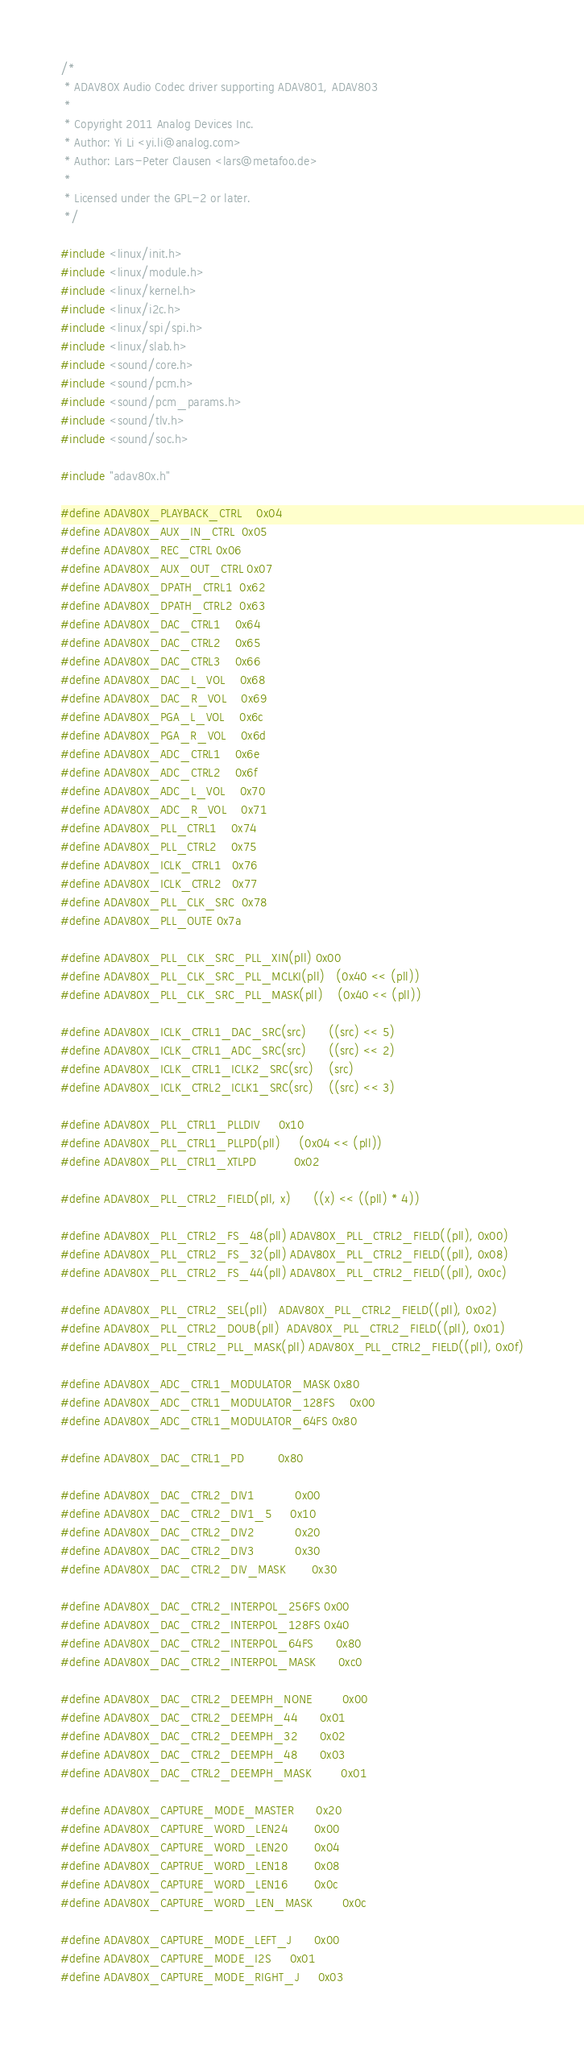Convert code to text. <code><loc_0><loc_0><loc_500><loc_500><_C_>/*
 * ADAV80X Audio Codec driver supporting ADAV801, ADAV803
 *
 * Copyright 2011 Analog Devices Inc.
 * Author: Yi Li <yi.li@analog.com>
 * Author: Lars-Peter Clausen <lars@metafoo.de>
 *
 * Licensed under the GPL-2 or later.
 */

#include <linux/init.h>
#include <linux/module.h>
#include <linux/kernel.h>
#include <linux/i2c.h>
#include <linux/spi/spi.h>
#include <linux/slab.h>
#include <sound/core.h>
#include <sound/pcm.h>
#include <sound/pcm_params.h>
#include <sound/tlv.h>
#include <sound/soc.h>

#include "adav80x.h"

#define ADAV80X_PLAYBACK_CTRL	0x04
#define ADAV80X_AUX_IN_CTRL	0x05
#define ADAV80X_REC_CTRL	0x06
#define ADAV80X_AUX_OUT_CTRL	0x07
#define ADAV80X_DPATH_CTRL1	0x62
#define ADAV80X_DPATH_CTRL2	0x63
#define ADAV80X_DAC_CTRL1	0x64
#define ADAV80X_DAC_CTRL2	0x65
#define ADAV80X_DAC_CTRL3	0x66
#define ADAV80X_DAC_L_VOL	0x68
#define ADAV80X_DAC_R_VOL	0x69
#define ADAV80X_PGA_L_VOL	0x6c
#define ADAV80X_PGA_R_VOL	0x6d
#define ADAV80X_ADC_CTRL1	0x6e
#define ADAV80X_ADC_CTRL2	0x6f
#define ADAV80X_ADC_L_VOL	0x70
#define ADAV80X_ADC_R_VOL	0x71
#define ADAV80X_PLL_CTRL1	0x74
#define ADAV80X_PLL_CTRL2	0x75
#define ADAV80X_ICLK_CTRL1	0x76
#define ADAV80X_ICLK_CTRL2	0x77
#define ADAV80X_PLL_CLK_SRC	0x78
#define ADAV80X_PLL_OUTE	0x7a

#define ADAV80X_PLL_CLK_SRC_PLL_XIN(pll)	0x00
#define ADAV80X_PLL_CLK_SRC_PLL_MCLKI(pll)	(0x40 << (pll))
#define ADAV80X_PLL_CLK_SRC_PLL_MASK(pll)	(0x40 << (pll))

#define ADAV80X_ICLK_CTRL1_DAC_SRC(src)		((src) << 5)
#define ADAV80X_ICLK_CTRL1_ADC_SRC(src)		((src) << 2)
#define ADAV80X_ICLK_CTRL1_ICLK2_SRC(src)	(src)
#define ADAV80X_ICLK_CTRL2_ICLK1_SRC(src)	((src) << 3)

#define ADAV80X_PLL_CTRL1_PLLDIV		0x10
#define ADAV80X_PLL_CTRL1_PLLPD(pll)		(0x04 << (pll))
#define ADAV80X_PLL_CTRL1_XTLPD			0x02

#define ADAV80X_PLL_CTRL2_FIELD(pll, x)		((x) << ((pll) * 4))

#define ADAV80X_PLL_CTRL2_FS_48(pll)	ADAV80X_PLL_CTRL2_FIELD((pll), 0x00)
#define ADAV80X_PLL_CTRL2_FS_32(pll)	ADAV80X_PLL_CTRL2_FIELD((pll), 0x08)
#define ADAV80X_PLL_CTRL2_FS_44(pll)	ADAV80X_PLL_CTRL2_FIELD((pll), 0x0c)

#define ADAV80X_PLL_CTRL2_SEL(pll)	ADAV80X_PLL_CTRL2_FIELD((pll), 0x02)
#define ADAV80X_PLL_CTRL2_DOUB(pll)	ADAV80X_PLL_CTRL2_FIELD((pll), 0x01)
#define ADAV80X_PLL_CTRL2_PLL_MASK(pll) ADAV80X_PLL_CTRL2_FIELD((pll), 0x0f)

#define ADAV80X_ADC_CTRL1_MODULATOR_MASK	0x80
#define ADAV80X_ADC_CTRL1_MODULATOR_128FS	0x00
#define ADAV80X_ADC_CTRL1_MODULATOR_64FS	0x80

#define ADAV80X_DAC_CTRL1_PD			0x80

#define ADAV80X_DAC_CTRL2_DIV1			0x00
#define ADAV80X_DAC_CTRL2_DIV1_5		0x10
#define ADAV80X_DAC_CTRL2_DIV2			0x20
#define ADAV80X_DAC_CTRL2_DIV3			0x30
#define ADAV80X_DAC_CTRL2_DIV_MASK		0x30

#define ADAV80X_DAC_CTRL2_INTERPOL_256FS	0x00
#define ADAV80X_DAC_CTRL2_INTERPOL_128FS	0x40
#define ADAV80X_DAC_CTRL2_INTERPOL_64FS		0x80
#define ADAV80X_DAC_CTRL2_INTERPOL_MASK		0xc0

#define ADAV80X_DAC_CTRL2_DEEMPH_NONE		0x00
#define ADAV80X_DAC_CTRL2_DEEMPH_44		0x01
#define ADAV80X_DAC_CTRL2_DEEMPH_32		0x02
#define ADAV80X_DAC_CTRL2_DEEMPH_48		0x03
#define ADAV80X_DAC_CTRL2_DEEMPH_MASK		0x01

#define ADAV80X_CAPTURE_MODE_MASTER		0x20
#define ADAV80X_CAPTURE_WORD_LEN24		0x00
#define ADAV80X_CAPTURE_WORD_LEN20		0x04
#define ADAV80X_CAPTRUE_WORD_LEN18		0x08
#define ADAV80X_CAPTURE_WORD_LEN16		0x0c
#define ADAV80X_CAPTURE_WORD_LEN_MASK		0x0c

#define ADAV80X_CAPTURE_MODE_LEFT_J		0x00
#define ADAV80X_CAPTURE_MODE_I2S		0x01
#define ADAV80X_CAPTURE_MODE_RIGHT_J		0x03</code> 